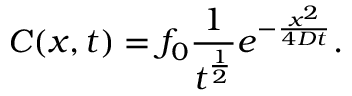Convert formula to latex. <formula><loc_0><loc_0><loc_500><loc_500>C ( x , t ) = f _ { 0 } \frac { 1 } { t ^ { \frac { 1 } { 2 } } } e ^ { - \frac { x ^ { 2 } } { 4 D t } } .</formula> 